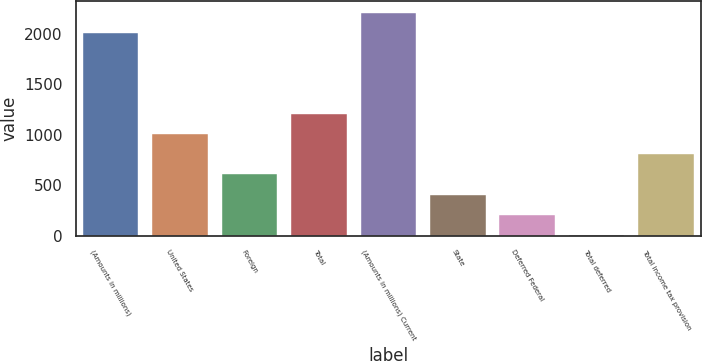<chart> <loc_0><loc_0><loc_500><loc_500><bar_chart><fcel>(Amounts in millions)<fcel>United States<fcel>Foreign<fcel>Total<fcel>(Amounts in millions) Current<fcel>State<fcel>Deferred Federal<fcel>Total deferred<fcel>Total income tax provision<nl><fcel>2011<fcel>1008.05<fcel>606.87<fcel>1208.64<fcel>2211.59<fcel>406.28<fcel>205.69<fcel>5.1<fcel>807.46<nl></chart> 